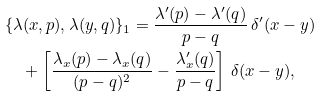Convert formula to latex. <formula><loc_0><loc_0><loc_500><loc_500>& \{ \lambda ( x , p ) , \lambda ( y , q ) \} _ { 1 } = \frac { \lambda ^ { \prime } ( p ) - \lambda ^ { \prime } ( q ) } { p - q } \, \delta ^ { \prime } ( x - y ) \\ & \quad + \left [ \frac { \lambda _ { x } ( p ) - \lambda _ { x } ( q ) } { ( p - q ) ^ { 2 } } - \frac { \lambda ^ { \prime } _ { x } ( q ) } { p - q } \right ] \, \delta ( x - y ) ,</formula> 